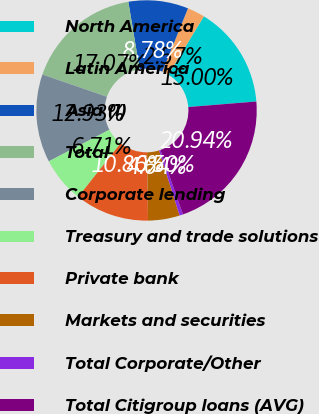<chart> <loc_0><loc_0><loc_500><loc_500><pie_chart><fcel>North America<fcel>Latin America<fcel>Asia (1)<fcel>Total<fcel>Corporate lending<fcel>Treasury and trade solutions<fcel>Private bank<fcel>Markets and securities<fcel>Total Corporate/Other<fcel>Total Citigroup loans (AVG)<nl><fcel>15.0%<fcel>2.57%<fcel>8.78%<fcel>17.07%<fcel>12.93%<fcel>6.71%<fcel>10.86%<fcel>4.64%<fcel>0.5%<fcel>20.94%<nl></chart> 